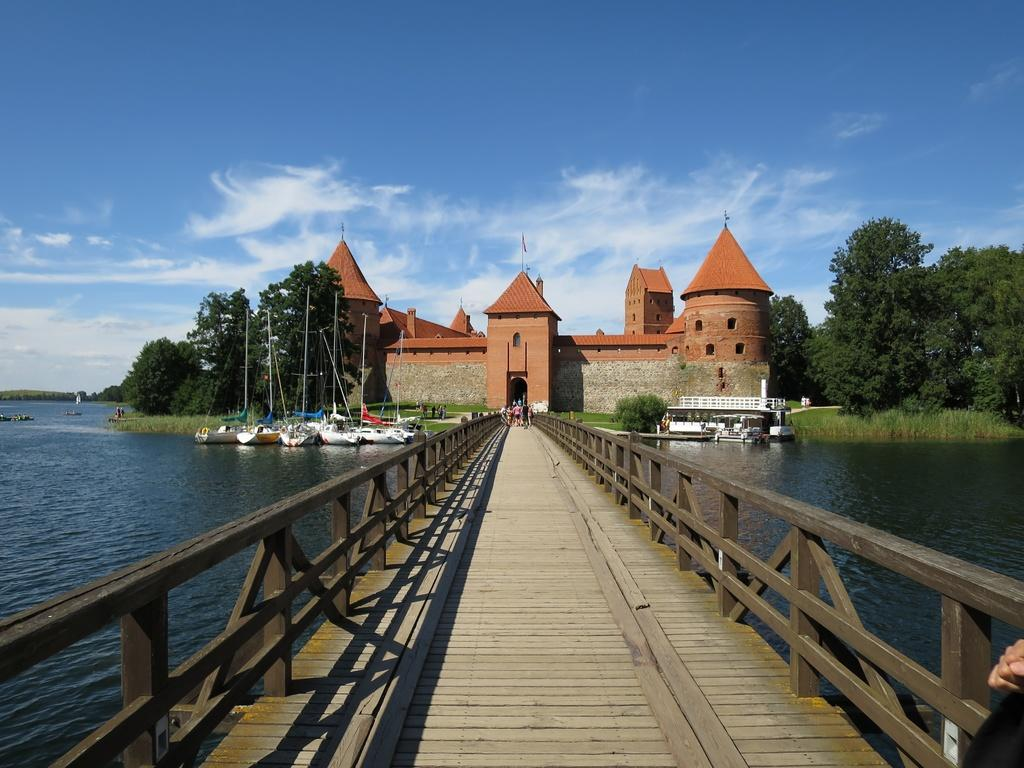What type of structure is in the image? There is a walkway bridge in the image. Who or what is on the bridge? People are standing on the bridge. What can be seen on the water below the bridge? There are ships on the water. What type of vegetation is present in the image? Grass is present in the image, and trees are visible as well. What type of building can be seen in the image? There is a castle in the image. What is visible in the sky? The sky is visible in the image, and clouds are present. What type of letter is being delivered by the boat on the water? There is no boat delivering a letter in the image. What type of curtain is hanging from the castle? There are no curtains visible in the image. 